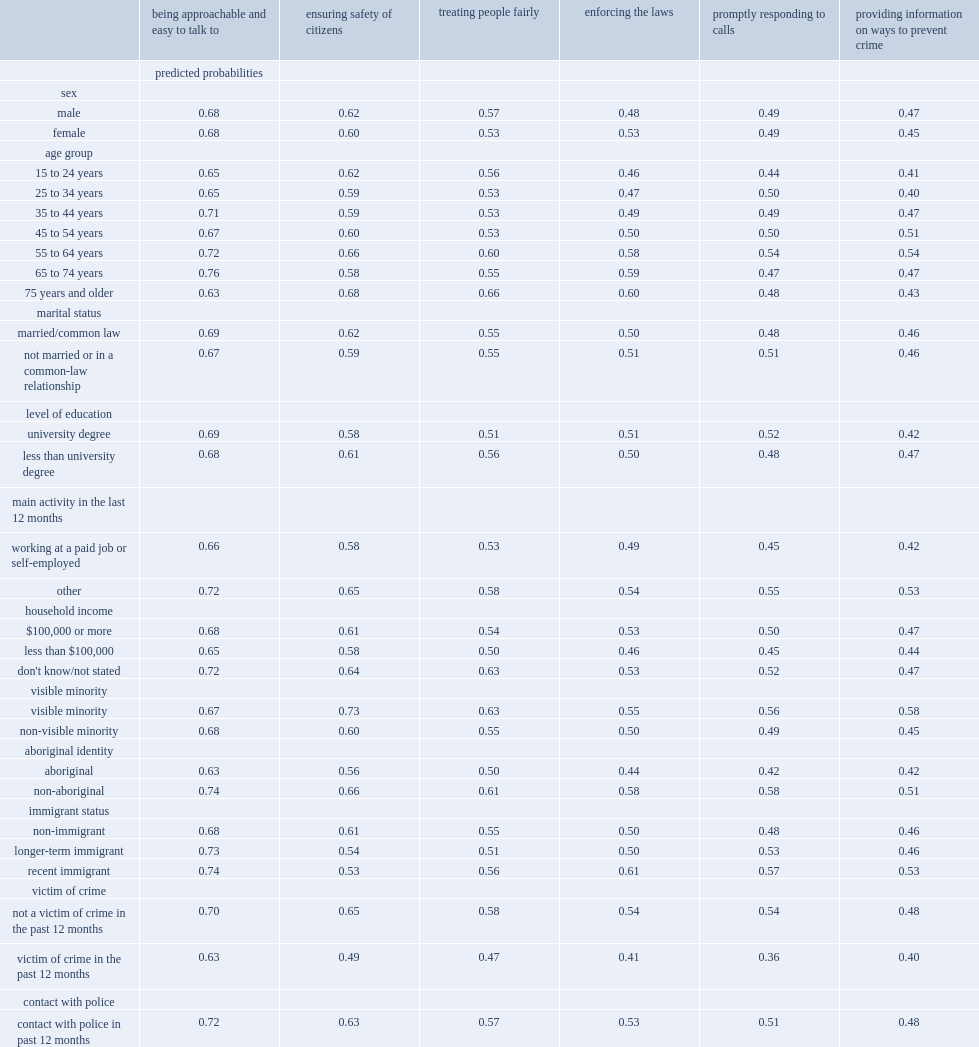Which group of people are more likely to rate police performance lower? aboriginal people or non-aboriginal people? Aboriginal. Which group of people are more likely to rate police performance lower? those who were the victim of a crime in the previous 12 months or non-victims? Victim of crime. 